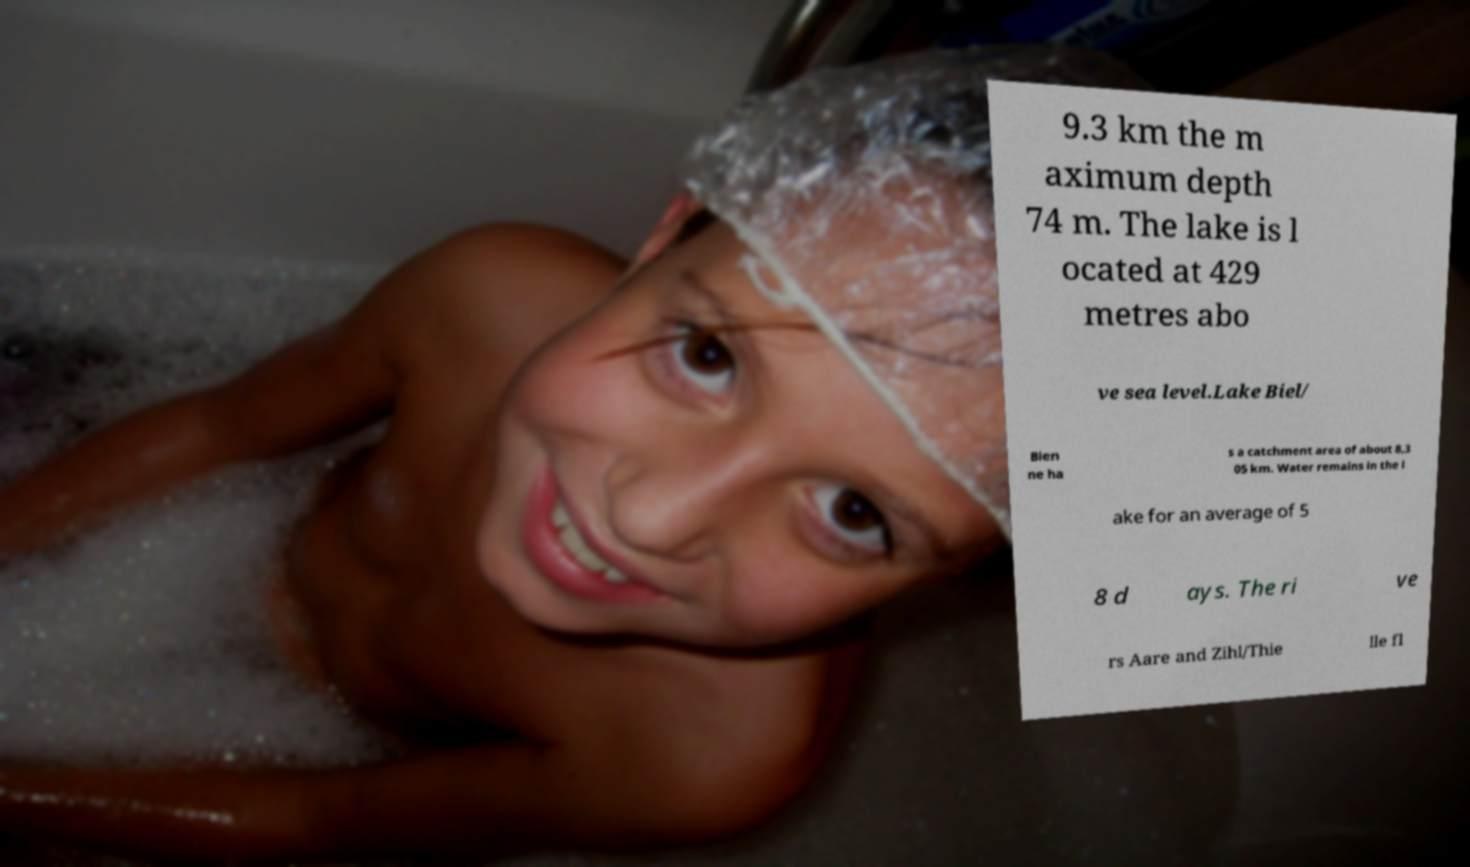There's text embedded in this image that I need extracted. Can you transcribe it verbatim? 9.3 km the m aximum depth 74 m. The lake is l ocated at 429 metres abo ve sea level.Lake Biel/ Bien ne ha s a catchment area of about 8,3 05 km. Water remains in the l ake for an average of 5 8 d ays. The ri ve rs Aare and Zihl/Thie lle fl 